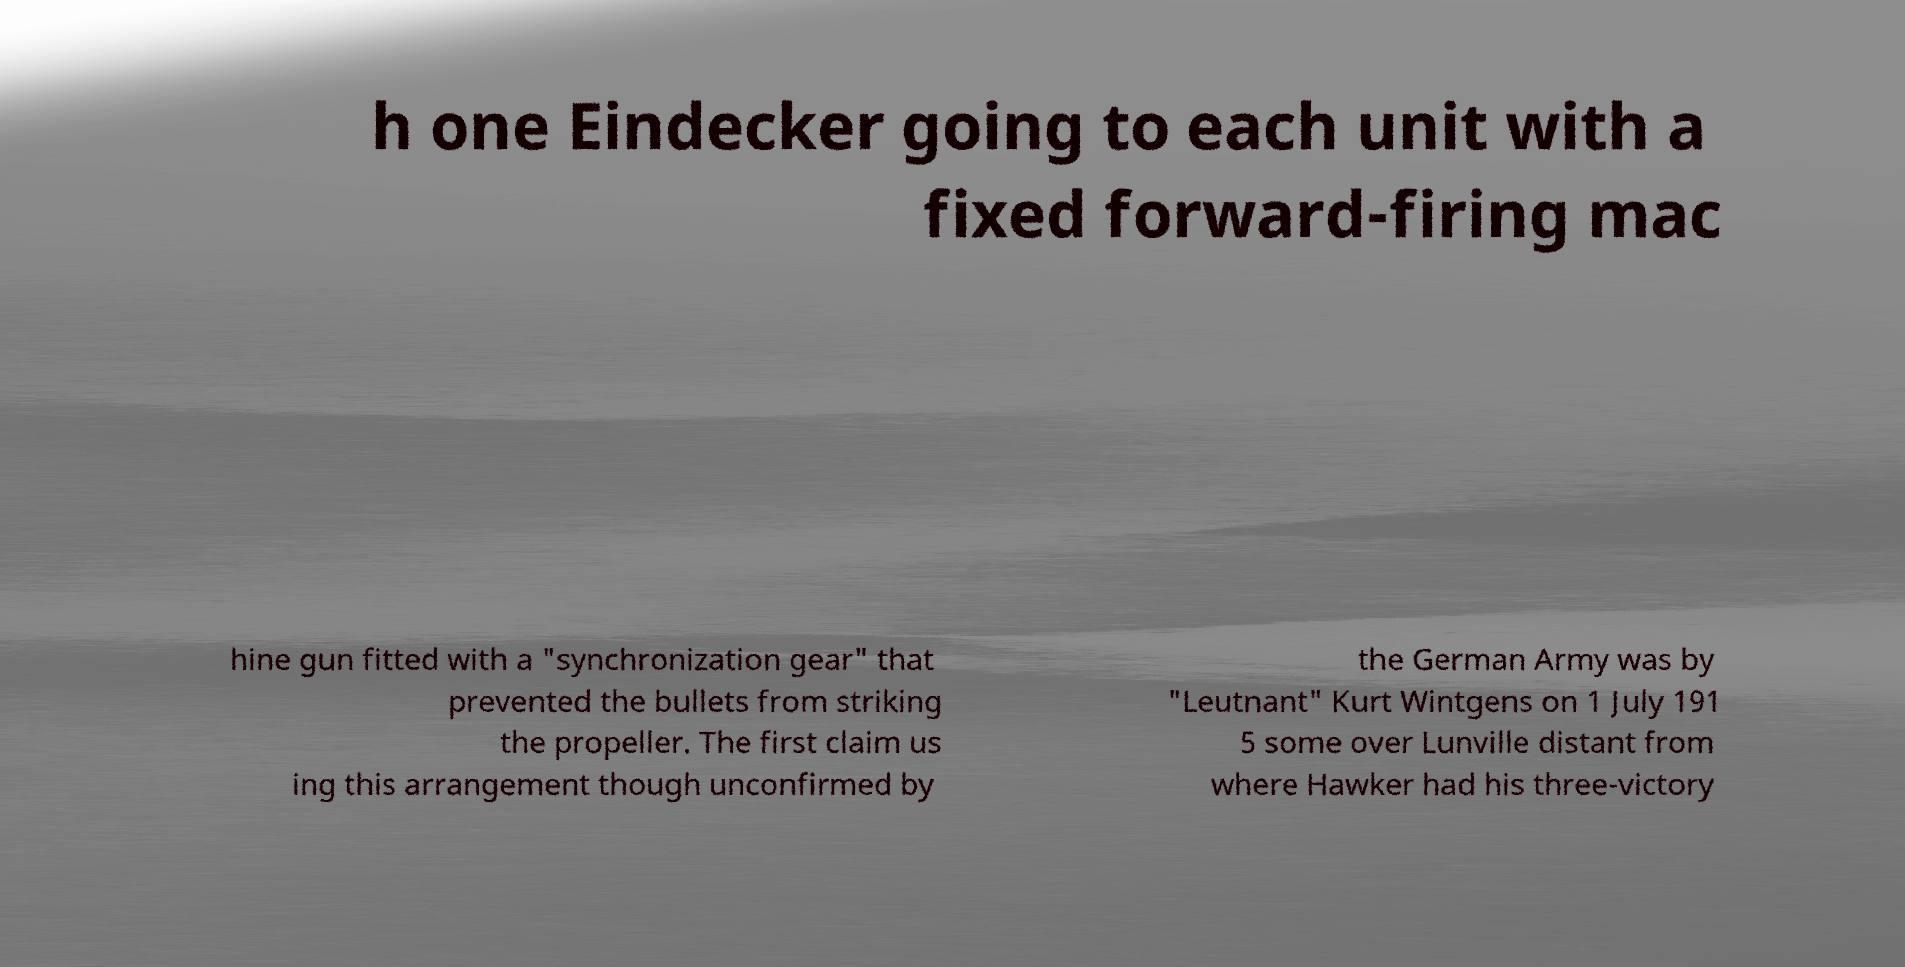Could you extract and type out the text from this image? h one Eindecker going to each unit with a fixed forward-firing mac hine gun fitted with a "synchronization gear" that prevented the bullets from striking the propeller. The first claim us ing this arrangement though unconfirmed by the German Army was by "Leutnant" Kurt Wintgens on 1 July 191 5 some over Lunville distant from where Hawker had his three-victory 